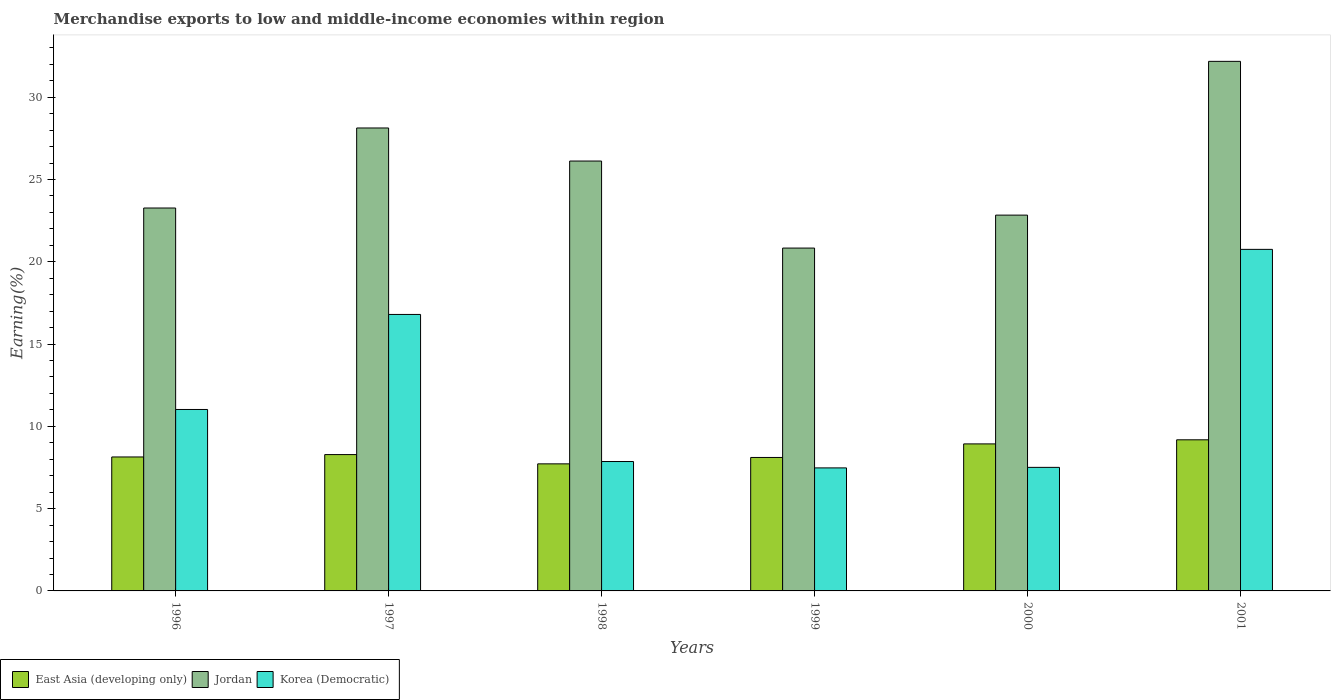How many different coloured bars are there?
Keep it short and to the point. 3. Are the number of bars on each tick of the X-axis equal?
Keep it short and to the point. Yes. How many bars are there on the 2nd tick from the right?
Your answer should be compact. 3. In how many cases, is the number of bars for a given year not equal to the number of legend labels?
Offer a very short reply. 0. What is the percentage of amount earned from merchandise exports in Korea (Democratic) in 2001?
Your answer should be very brief. 20.75. Across all years, what is the maximum percentage of amount earned from merchandise exports in Jordan?
Your answer should be compact. 32.18. Across all years, what is the minimum percentage of amount earned from merchandise exports in Korea (Democratic)?
Provide a short and direct response. 7.48. In which year was the percentage of amount earned from merchandise exports in East Asia (developing only) minimum?
Provide a succinct answer. 1998. What is the total percentage of amount earned from merchandise exports in Korea (Democratic) in the graph?
Your answer should be compact. 71.43. What is the difference between the percentage of amount earned from merchandise exports in Korea (Democratic) in 1996 and that in 1999?
Offer a terse response. 3.55. What is the difference between the percentage of amount earned from merchandise exports in East Asia (developing only) in 1998 and the percentage of amount earned from merchandise exports in Korea (Democratic) in 1997?
Provide a succinct answer. -9.08. What is the average percentage of amount earned from merchandise exports in Jordan per year?
Keep it short and to the point. 25.56. In the year 2000, what is the difference between the percentage of amount earned from merchandise exports in East Asia (developing only) and percentage of amount earned from merchandise exports in Jordan?
Make the answer very short. -13.9. What is the ratio of the percentage of amount earned from merchandise exports in Jordan in 1997 to that in 2001?
Make the answer very short. 0.87. Is the difference between the percentage of amount earned from merchandise exports in East Asia (developing only) in 1997 and 1999 greater than the difference between the percentage of amount earned from merchandise exports in Jordan in 1997 and 1999?
Keep it short and to the point. No. What is the difference between the highest and the second highest percentage of amount earned from merchandise exports in East Asia (developing only)?
Give a very brief answer. 0.25. What is the difference between the highest and the lowest percentage of amount earned from merchandise exports in East Asia (developing only)?
Your response must be concise. 1.46. In how many years, is the percentage of amount earned from merchandise exports in Korea (Democratic) greater than the average percentage of amount earned from merchandise exports in Korea (Democratic) taken over all years?
Offer a very short reply. 2. Is the sum of the percentage of amount earned from merchandise exports in Korea (Democratic) in 1998 and 1999 greater than the maximum percentage of amount earned from merchandise exports in East Asia (developing only) across all years?
Ensure brevity in your answer.  Yes. What does the 1st bar from the left in 1998 represents?
Your answer should be very brief. East Asia (developing only). What does the 2nd bar from the right in 2001 represents?
Ensure brevity in your answer.  Jordan. Are all the bars in the graph horizontal?
Offer a very short reply. No. How many years are there in the graph?
Provide a succinct answer. 6. What is the difference between two consecutive major ticks on the Y-axis?
Make the answer very short. 5. Does the graph contain any zero values?
Make the answer very short. No. Where does the legend appear in the graph?
Provide a short and direct response. Bottom left. How many legend labels are there?
Give a very brief answer. 3. How are the legend labels stacked?
Your answer should be compact. Horizontal. What is the title of the graph?
Provide a short and direct response. Merchandise exports to low and middle-income economies within region. What is the label or title of the X-axis?
Your answer should be very brief. Years. What is the label or title of the Y-axis?
Ensure brevity in your answer.  Earning(%). What is the Earning(%) in East Asia (developing only) in 1996?
Ensure brevity in your answer.  8.14. What is the Earning(%) in Jordan in 1996?
Offer a very short reply. 23.27. What is the Earning(%) of Korea (Democratic) in 1996?
Provide a short and direct response. 11.03. What is the Earning(%) of East Asia (developing only) in 1997?
Your answer should be compact. 8.28. What is the Earning(%) of Jordan in 1997?
Provide a succinct answer. 28.13. What is the Earning(%) of Korea (Democratic) in 1997?
Your answer should be very brief. 16.8. What is the Earning(%) of East Asia (developing only) in 1998?
Provide a short and direct response. 7.72. What is the Earning(%) in Jordan in 1998?
Your response must be concise. 26.12. What is the Earning(%) in Korea (Democratic) in 1998?
Your response must be concise. 7.86. What is the Earning(%) of East Asia (developing only) in 1999?
Ensure brevity in your answer.  8.11. What is the Earning(%) of Jordan in 1999?
Ensure brevity in your answer.  20.83. What is the Earning(%) of Korea (Democratic) in 1999?
Provide a succinct answer. 7.48. What is the Earning(%) of East Asia (developing only) in 2000?
Provide a succinct answer. 8.93. What is the Earning(%) in Jordan in 2000?
Your answer should be very brief. 22.84. What is the Earning(%) in Korea (Democratic) in 2000?
Offer a terse response. 7.51. What is the Earning(%) of East Asia (developing only) in 2001?
Make the answer very short. 9.18. What is the Earning(%) of Jordan in 2001?
Provide a succinct answer. 32.18. What is the Earning(%) in Korea (Democratic) in 2001?
Your response must be concise. 20.75. Across all years, what is the maximum Earning(%) in East Asia (developing only)?
Your answer should be compact. 9.18. Across all years, what is the maximum Earning(%) in Jordan?
Provide a short and direct response. 32.18. Across all years, what is the maximum Earning(%) of Korea (Democratic)?
Your answer should be compact. 20.75. Across all years, what is the minimum Earning(%) in East Asia (developing only)?
Offer a terse response. 7.72. Across all years, what is the minimum Earning(%) of Jordan?
Offer a very short reply. 20.83. Across all years, what is the minimum Earning(%) in Korea (Democratic)?
Give a very brief answer. 7.48. What is the total Earning(%) in East Asia (developing only) in the graph?
Offer a terse response. 50.37. What is the total Earning(%) in Jordan in the graph?
Provide a short and direct response. 153.37. What is the total Earning(%) in Korea (Democratic) in the graph?
Provide a succinct answer. 71.43. What is the difference between the Earning(%) in East Asia (developing only) in 1996 and that in 1997?
Give a very brief answer. -0.14. What is the difference between the Earning(%) in Jordan in 1996 and that in 1997?
Provide a short and direct response. -4.86. What is the difference between the Earning(%) of Korea (Democratic) in 1996 and that in 1997?
Provide a succinct answer. -5.77. What is the difference between the Earning(%) of East Asia (developing only) in 1996 and that in 1998?
Keep it short and to the point. 0.42. What is the difference between the Earning(%) of Jordan in 1996 and that in 1998?
Your response must be concise. -2.85. What is the difference between the Earning(%) of Korea (Democratic) in 1996 and that in 1998?
Provide a succinct answer. 3.16. What is the difference between the Earning(%) in East Asia (developing only) in 1996 and that in 1999?
Provide a short and direct response. 0.03. What is the difference between the Earning(%) in Jordan in 1996 and that in 1999?
Your response must be concise. 2.43. What is the difference between the Earning(%) of Korea (Democratic) in 1996 and that in 1999?
Provide a short and direct response. 3.55. What is the difference between the Earning(%) in East Asia (developing only) in 1996 and that in 2000?
Your answer should be compact. -0.79. What is the difference between the Earning(%) of Jordan in 1996 and that in 2000?
Your answer should be very brief. 0.43. What is the difference between the Earning(%) in Korea (Democratic) in 1996 and that in 2000?
Provide a short and direct response. 3.52. What is the difference between the Earning(%) in East Asia (developing only) in 1996 and that in 2001?
Your answer should be compact. -1.04. What is the difference between the Earning(%) of Jordan in 1996 and that in 2001?
Give a very brief answer. -8.91. What is the difference between the Earning(%) of Korea (Democratic) in 1996 and that in 2001?
Ensure brevity in your answer.  -9.73. What is the difference between the Earning(%) of East Asia (developing only) in 1997 and that in 1998?
Your response must be concise. 0.56. What is the difference between the Earning(%) of Jordan in 1997 and that in 1998?
Offer a terse response. 2.01. What is the difference between the Earning(%) of Korea (Democratic) in 1997 and that in 1998?
Provide a short and direct response. 8.94. What is the difference between the Earning(%) of East Asia (developing only) in 1997 and that in 1999?
Offer a terse response. 0.18. What is the difference between the Earning(%) of Jordan in 1997 and that in 1999?
Ensure brevity in your answer.  7.3. What is the difference between the Earning(%) of Korea (Democratic) in 1997 and that in 1999?
Offer a very short reply. 9.32. What is the difference between the Earning(%) in East Asia (developing only) in 1997 and that in 2000?
Provide a succinct answer. -0.65. What is the difference between the Earning(%) in Jordan in 1997 and that in 2000?
Your answer should be compact. 5.29. What is the difference between the Earning(%) of Korea (Democratic) in 1997 and that in 2000?
Your response must be concise. 9.29. What is the difference between the Earning(%) of East Asia (developing only) in 1997 and that in 2001?
Offer a very short reply. -0.9. What is the difference between the Earning(%) of Jordan in 1997 and that in 2001?
Offer a very short reply. -4.05. What is the difference between the Earning(%) of Korea (Democratic) in 1997 and that in 2001?
Make the answer very short. -3.95. What is the difference between the Earning(%) in East Asia (developing only) in 1998 and that in 1999?
Provide a succinct answer. -0.39. What is the difference between the Earning(%) in Jordan in 1998 and that in 1999?
Make the answer very short. 5.29. What is the difference between the Earning(%) of Korea (Democratic) in 1998 and that in 1999?
Give a very brief answer. 0.39. What is the difference between the Earning(%) of East Asia (developing only) in 1998 and that in 2000?
Your answer should be very brief. -1.21. What is the difference between the Earning(%) of Jordan in 1998 and that in 2000?
Your response must be concise. 3.29. What is the difference between the Earning(%) of Korea (Democratic) in 1998 and that in 2000?
Keep it short and to the point. 0.35. What is the difference between the Earning(%) in East Asia (developing only) in 1998 and that in 2001?
Offer a terse response. -1.46. What is the difference between the Earning(%) in Jordan in 1998 and that in 2001?
Keep it short and to the point. -6.06. What is the difference between the Earning(%) of Korea (Democratic) in 1998 and that in 2001?
Your answer should be compact. -12.89. What is the difference between the Earning(%) of East Asia (developing only) in 1999 and that in 2000?
Keep it short and to the point. -0.82. What is the difference between the Earning(%) in Jordan in 1999 and that in 2000?
Ensure brevity in your answer.  -2. What is the difference between the Earning(%) in Korea (Democratic) in 1999 and that in 2000?
Ensure brevity in your answer.  -0.03. What is the difference between the Earning(%) of East Asia (developing only) in 1999 and that in 2001?
Provide a succinct answer. -1.07. What is the difference between the Earning(%) in Jordan in 1999 and that in 2001?
Your answer should be very brief. -11.35. What is the difference between the Earning(%) in Korea (Democratic) in 1999 and that in 2001?
Provide a succinct answer. -13.28. What is the difference between the Earning(%) of East Asia (developing only) in 2000 and that in 2001?
Offer a terse response. -0.25. What is the difference between the Earning(%) of Jordan in 2000 and that in 2001?
Offer a very short reply. -9.34. What is the difference between the Earning(%) in Korea (Democratic) in 2000 and that in 2001?
Make the answer very short. -13.25. What is the difference between the Earning(%) of East Asia (developing only) in 1996 and the Earning(%) of Jordan in 1997?
Ensure brevity in your answer.  -19.99. What is the difference between the Earning(%) of East Asia (developing only) in 1996 and the Earning(%) of Korea (Democratic) in 1997?
Your response must be concise. -8.66. What is the difference between the Earning(%) in Jordan in 1996 and the Earning(%) in Korea (Democratic) in 1997?
Your answer should be very brief. 6.47. What is the difference between the Earning(%) in East Asia (developing only) in 1996 and the Earning(%) in Jordan in 1998?
Your answer should be very brief. -17.98. What is the difference between the Earning(%) in East Asia (developing only) in 1996 and the Earning(%) in Korea (Democratic) in 1998?
Your answer should be compact. 0.28. What is the difference between the Earning(%) of Jordan in 1996 and the Earning(%) of Korea (Democratic) in 1998?
Make the answer very short. 15.4. What is the difference between the Earning(%) in East Asia (developing only) in 1996 and the Earning(%) in Jordan in 1999?
Offer a very short reply. -12.69. What is the difference between the Earning(%) of East Asia (developing only) in 1996 and the Earning(%) of Korea (Democratic) in 1999?
Offer a very short reply. 0.66. What is the difference between the Earning(%) in Jordan in 1996 and the Earning(%) in Korea (Democratic) in 1999?
Offer a terse response. 15.79. What is the difference between the Earning(%) of East Asia (developing only) in 1996 and the Earning(%) of Jordan in 2000?
Give a very brief answer. -14.7. What is the difference between the Earning(%) of East Asia (developing only) in 1996 and the Earning(%) of Korea (Democratic) in 2000?
Provide a short and direct response. 0.63. What is the difference between the Earning(%) in Jordan in 1996 and the Earning(%) in Korea (Democratic) in 2000?
Make the answer very short. 15.76. What is the difference between the Earning(%) in East Asia (developing only) in 1996 and the Earning(%) in Jordan in 2001?
Your answer should be very brief. -24.04. What is the difference between the Earning(%) in East Asia (developing only) in 1996 and the Earning(%) in Korea (Democratic) in 2001?
Provide a succinct answer. -12.61. What is the difference between the Earning(%) of Jordan in 1996 and the Earning(%) of Korea (Democratic) in 2001?
Offer a very short reply. 2.51. What is the difference between the Earning(%) of East Asia (developing only) in 1997 and the Earning(%) of Jordan in 1998?
Your answer should be compact. -17.84. What is the difference between the Earning(%) of East Asia (developing only) in 1997 and the Earning(%) of Korea (Democratic) in 1998?
Your answer should be compact. 0.42. What is the difference between the Earning(%) of Jordan in 1997 and the Earning(%) of Korea (Democratic) in 1998?
Ensure brevity in your answer.  20.27. What is the difference between the Earning(%) of East Asia (developing only) in 1997 and the Earning(%) of Jordan in 1999?
Provide a succinct answer. -12.55. What is the difference between the Earning(%) of East Asia (developing only) in 1997 and the Earning(%) of Korea (Democratic) in 1999?
Make the answer very short. 0.81. What is the difference between the Earning(%) in Jordan in 1997 and the Earning(%) in Korea (Democratic) in 1999?
Offer a very short reply. 20.65. What is the difference between the Earning(%) of East Asia (developing only) in 1997 and the Earning(%) of Jordan in 2000?
Make the answer very short. -14.55. What is the difference between the Earning(%) in East Asia (developing only) in 1997 and the Earning(%) in Korea (Democratic) in 2000?
Offer a very short reply. 0.78. What is the difference between the Earning(%) in Jordan in 1997 and the Earning(%) in Korea (Democratic) in 2000?
Keep it short and to the point. 20.62. What is the difference between the Earning(%) of East Asia (developing only) in 1997 and the Earning(%) of Jordan in 2001?
Make the answer very short. -23.89. What is the difference between the Earning(%) in East Asia (developing only) in 1997 and the Earning(%) in Korea (Democratic) in 2001?
Your response must be concise. -12.47. What is the difference between the Earning(%) of Jordan in 1997 and the Earning(%) of Korea (Democratic) in 2001?
Give a very brief answer. 7.38. What is the difference between the Earning(%) in East Asia (developing only) in 1998 and the Earning(%) in Jordan in 1999?
Offer a terse response. -13.11. What is the difference between the Earning(%) in East Asia (developing only) in 1998 and the Earning(%) in Korea (Democratic) in 1999?
Your answer should be very brief. 0.25. What is the difference between the Earning(%) in Jordan in 1998 and the Earning(%) in Korea (Democratic) in 1999?
Your answer should be compact. 18.65. What is the difference between the Earning(%) of East Asia (developing only) in 1998 and the Earning(%) of Jordan in 2000?
Give a very brief answer. -15.11. What is the difference between the Earning(%) of East Asia (developing only) in 1998 and the Earning(%) of Korea (Democratic) in 2000?
Your response must be concise. 0.21. What is the difference between the Earning(%) of Jordan in 1998 and the Earning(%) of Korea (Democratic) in 2000?
Your response must be concise. 18.61. What is the difference between the Earning(%) in East Asia (developing only) in 1998 and the Earning(%) in Jordan in 2001?
Make the answer very short. -24.46. What is the difference between the Earning(%) in East Asia (developing only) in 1998 and the Earning(%) in Korea (Democratic) in 2001?
Offer a very short reply. -13.03. What is the difference between the Earning(%) of Jordan in 1998 and the Earning(%) of Korea (Democratic) in 2001?
Make the answer very short. 5.37. What is the difference between the Earning(%) of East Asia (developing only) in 1999 and the Earning(%) of Jordan in 2000?
Provide a succinct answer. -14.73. What is the difference between the Earning(%) of East Asia (developing only) in 1999 and the Earning(%) of Korea (Democratic) in 2000?
Your answer should be compact. 0.6. What is the difference between the Earning(%) in Jordan in 1999 and the Earning(%) in Korea (Democratic) in 2000?
Your answer should be very brief. 13.33. What is the difference between the Earning(%) of East Asia (developing only) in 1999 and the Earning(%) of Jordan in 2001?
Make the answer very short. -24.07. What is the difference between the Earning(%) of East Asia (developing only) in 1999 and the Earning(%) of Korea (Democratic) in 2001?
Give a very brief answer. -12.65. What is the difference between the Earning(%) in Jordan in 1999 and the Earning(%) in Korea (Democratic) in 2001?
Your answer should be very brief. 0.08. What is the difference between the Earning(%) of East Asia (developing only) in 2000 and the Earning(%) of Jordan in 2001?
Give a very brief answer. -23.24. What is the difference between the Earning(%) in East Asia (developing only) in 2000 and the Earning(%) in Korea (Democratic) in 2001?
Your response must be concise. -11.82. What is the difference between the Earning(%) in Jordan in 2000 and the Earning(%) in Korea (Democratic) in 2001?
Your response must be concise. 2.08. What is the average Earning(%) in East Asia (developing only) per year?
Provide a short and direct response. 8.4. What is the average Earning(%) of Jordan per year?
Offer a terse response. 25.56. What is the average Earning(%) of Korea (Democratic) per year?
Your answer should be very brief. 11.9. In the year 1996, what is the difference between the Earning(%) of East Asia (developing only) and Earning(%) of Jordan?
Provide a short and direct response. -15.13. In the year 1996, what is the difference between the Earning(%) of East Asia (developing only) and Earning(%) of Korea (Democratic)?
Provide a short and direct response. -2.88. In the year 1996, what is the difference between the Earning(%) of Jordan and Earning(%) of Korea (Democratic)?
Offer a very short reply. 12.24. In the year 1997, what is the difference between the Earning(%) in East Asia (developing only) and Earning(%) in Jordan?
Provide a succinct answer. -19.85. In the year 1997, what is the difference between the Earning(%) of East Asia (developing only) and Earning(%) of Korea (Democratic)?
Your answer should be compact. -8.52. In the year 1997, what is the difference between the Earning(%) in Jordan and Earning(%) in Korea (Democratic)?
Provide a succinct answer. 11.33. In the year 1998, what is the difference between the Earning(%) of East Asia (developing only) and Earning(%) of Jordan?
Your answer should be compact. -18.4. In the year 1998, what is the difference between the Earning(%) in East Asia (developing only) and Earning(%) in Korea (Democratic)?
Make the answer very short. -0.14. In the year 1998, what is the difference between the Earning(%) of Jordan and Earning(%) of Korea (Democratic)?
Give a very brief answer. 18.26. In the year 1999, what is the difference between the Earning(%) of East Asia (developing only) and Earning(%) of Jordan?
Provide a short and direct response. -12.72. In the year 1999, what is the difference between the Earning(%) in East Asia (developing only) and Earning(%) in Korea (Democratic)?
Your answer should be very brief. 0.63. In the year 1999, what is the difference between the Earning(%) of Jordan and Earning(%) of Korea (Democratic)?
Your answer should be very brief. 13.36. In the year 2000, what is the difference between the Earning(%) in East Asia (developing only) and Earning(%) in Jordan?
Ensure brevity in your answer.  -13.9. In the year 2000, what is the difference between the Earning(%) of East Asia (developing only) and Earning(%) of Korea (Democratic)?
Your answer should be compact. 1.43. In the year 2000, what is the difference between the Earning(%) of Jordan and Earning(%) of Korea (Democratic)?
Your answer should be very brief. 15.33. In the year 2001, what is the difference between the Earning(%) of East Asia (developing only) and Earning(%) of Jordan?
Your response must be concise. -23. In the year 2001, what is the difference between the Earning(%) of East Asia (developing only) and Earning(%) of Korea (Democratic)?
Keep it short and to the point. -11.57. In the year 2001, what is the difference between the Earning(%) of Jordan and Earning(%) of Korea (Democratic)?
Give a very brief answer. 11.42. What is the ratio of the Earning(%) in East Asia (developing only) in 1996 to that in 1997?
Give a very brief answer. 0.98. What is the ratio of the Earning(%) in Jordan in 1996 to that in 1997?
Provide a succinct answer. 0.83. What is the ratio of the Earning(%) of Korea (Democratic) in 1996 to that in 1997?
Provide a short and direct response. 0.66. What is the ratio of the Earning(%) in East Asia (developing only) in 1996 to that in 1998?
Ensure brevity in your answer.  1.05. What is the ratio of the Earning(%) of Jordan in 1996 to that in 1998?
Ensure brevity in your answer.  0.89. What is the ratio of the Earning(%) in Korea (Democratic) in 1996 to that in 1998?
Your answer should be very brief. 1.4. What is the ratio of the Earning(%) of Jordan in 1996 to that in 1999?
Your answer should be compact. 1.12. What is the ratio of the Earning(%) of Korea (Democratic) in 1996 to that in 1999?
Offer a terse response. 1.47. What is the ratio of the Earning(%) in East Asia (developing only) in 1996 to that in 2000?
Ensure brevity in your answer.  0.91. What is the ratio of the Earning(%) in Jordan in 1996 to that in 2000?
Your response must be concise. 1.02. What is the ratio of the Earning(%) in Korea (Democratic) in 1996 to that in 2000?
Make the answer very short. 1.47. What is the ratio of the Earning(%) of East Asia (developing only) in 1996 to that in 2001?
Offer a very short reply. 0.89. What is the ratio of the Earning(%) in Jordan in 1996 to that in 2001?
Provide a short and direct response. 0.72. What is the ratio of the Earning(%) of Korea (Democratic) in 1996 to that in 2001?
Provide a short and direct response. 0.53. What is the ratio of the Earning(%) in East Asia (developing only) in 1997 to that in 1998?
Offer a very short reply. 1.07. What is the ratio of the Earning(%) in Korea (Democratic) in 1997 to that in 1998?
Make the answer very short. 2.14. What is the ratio of the Earning(%) of East Asia (developing only) in 1997 to that in 1999?
Your answer should be very brief. 1.02. What is the ratio of the Earning(%) in Jordan in 1997 to that in 1999?
Ensure brevity in your answer.  1.35. What is the ratio of the Earning(%) in Korea (Democratic) in 1997 to that in 1999?
Offer a terse response. 2.25. What is the ratio of the Earning(%) of East Asia (developing only) in 1997 to that in 2000?
Your response must be concise. 0.93. What is the ratio of the Earning(%) in Jordan in 1997 to that in 2000?
Keep it short and to the point. 1.23. What is the ratio of the Earning(%) in Korea (Democratic) in 1997 to that in 2000?
Provide a succinct answer. 2.24. What is the ratio of the Earning(%) of East Asia (developing only) in 1997 to that in 2001?
Make the answer very short. 0.9. What is the ratio of the Earning(%) in Jordan in 1997 to that in 2001?
Your response must be concise. 0.87. What is the ratio of the Earning(%) of Korea (Democratic) in 1997 to that in 2001?
Provide a succinct answer. 0.81. What is the ratio of the Earning(%) in East Asia (developing only) in 1998 to that in 1999?
Ensure brevity in your answer.  0.95. What is the ratio of the Earning(%) in Jordan in 1998 to that in 1999?
Your response must be concise. 1.25. What is the ratio of the Earning(%) of Korea (Democratic) in 1998 to that in 1999?
Your answer should be compact. 1.05. What is the ratio of the Earning(%) in East Asia (developing only) in 1998 to that in 2000?
Provide a succinct answer. 0.86. What is the ratio of the Earning(%) in Jordan in 1998 to that in 2000?
Provide a short and direct response. 1.14. What is the ratio of the Earning(%) in Korea (Democratic) in 1998 to that in 2000?
Offer a terse response. 1.05. What is the ratio of the Earning(%) of East Asia (developing only) in 1998 to that in 2001?
Your answer should be very brief. 0.84. What is the ratio of the Earning(%) in Jordan in 1998 to that in 2001?
Provide a short and direct response. 0.81. What is the ratio of the Earning(%) in Korea (Democratic) in 1998 to that in 2001?
Your answer should be compact. 0.38. What is the ratio of the Earning(%) in East Asia (developing only) in 1999 to that in 2000?
Make the answer very short. 0.91. What is the ratio of the Earning(%) in Jordan in 1999 to that in 2000?
Make the answer very short. 0.91. What is the ratio of the Earning(%) in East Asia (developing only) in 1999 to that in 2001?
Your answer should be very brief. 0.88. What is the ratio of the Earning(%) in Jordan in 1999 to that in 2001?
Keep it short and to the point. 0.65. What is the ratio of the Earning(%) of Korea (Democratic) in 1999 to that in 2001?
Provide a short and direct response. 0.36. What is the ratio of the Earning(%) in East Asia (developing only) in 2000 to that in 2001?
Provide a short and direct response. 0.97. What is the ratio of the Earning(%) of Jordan in 2000 to that in 2001?
Your answer should be very brief. 0.71. What is the ratio of the Earning(%) of Korea (Democratic) in 2000 to that in 2001?
Keep it short and to the point. 0.36. What is the difference between the highest and the second highest Earning(%) in East Asia (developing only)?
Keep it short and to the point. 0.25. What is the difference between the highest and the second highest Earning(%) in Jordan?
Keep it short and to the point. 4.05. What is the difference between the highest and the second highest Earning(%) in Korea (Democratic)?
Offer a very short reply. 3.95. What is the difference between the highest and the lowest Earning(%) in East Asia (developing only)?
Your answer should be compact. 1.46. What is the difference between the highest and the lowest Earning(%) in Jordan?
Your answer should be very brief. 11.35. What is the difference between the highest and the lowest Earning(%) of Korea (Democratic)?
Provide a succinct answer. 13.28. 